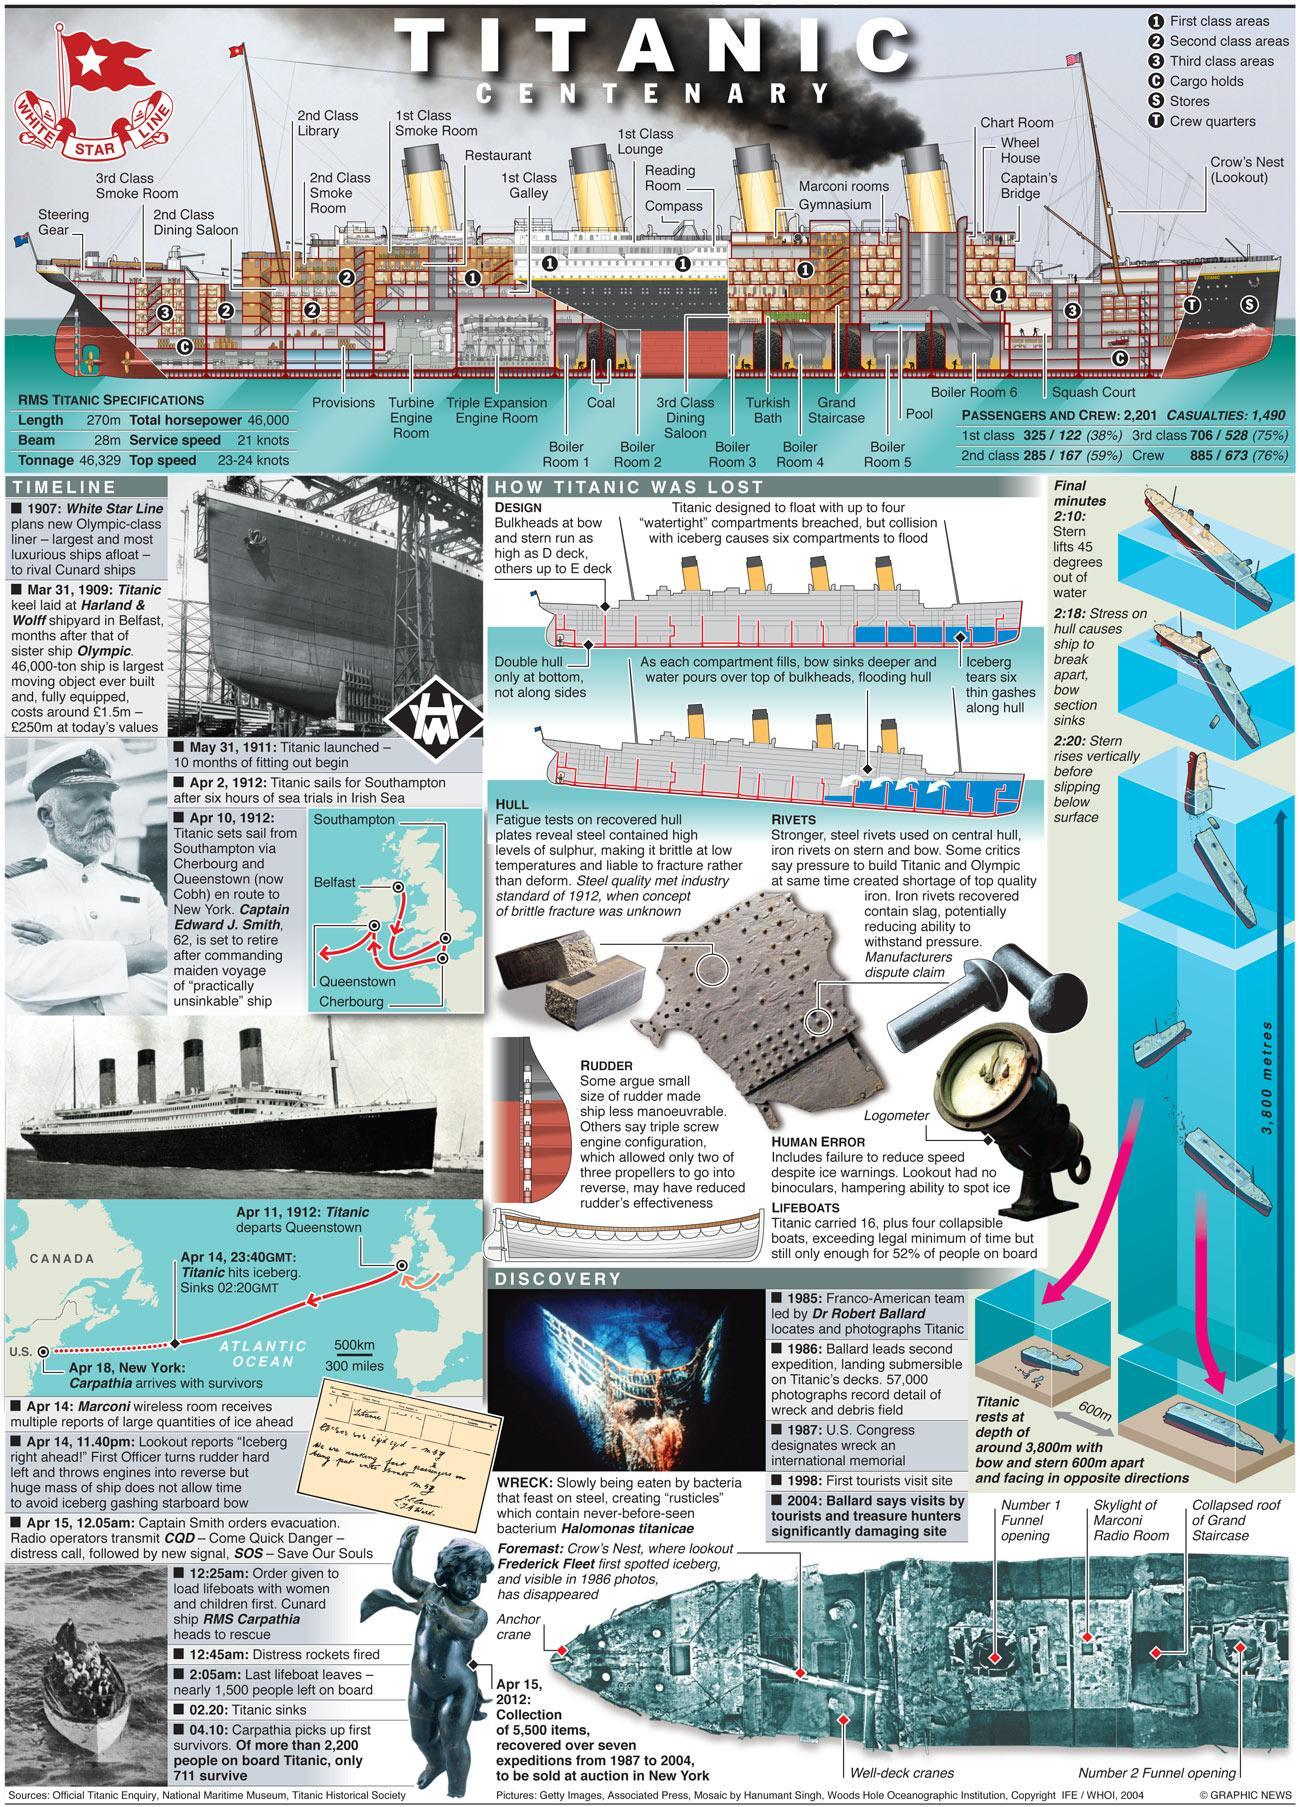What is the number of cargo holds?
Answer the question with a short phrase. 2 How many second class areas? 3 How many third-class areas? 2 Which all are the second class areas? Dining Saloon, Library, Smoke Room How many first-class areas? 5 